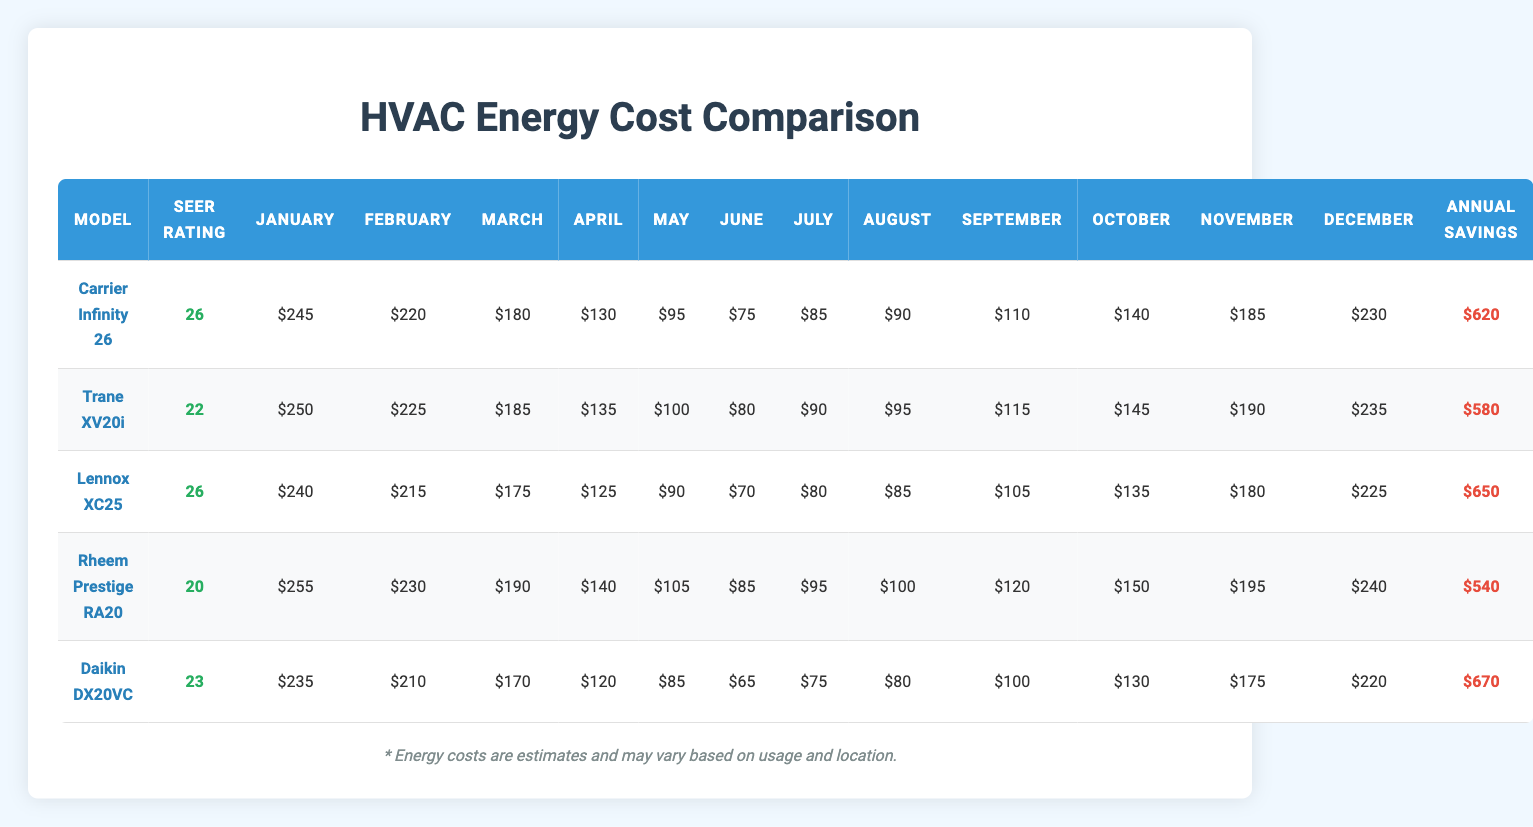What is the energy cost for the Carrier Infinity 26 in July? From the table, locate the row for the "Carrier Infinity 26" model. In the July column, the energy cost listed is $85.
Answer: $85 Which model has the highest SEER rating? By comparing the SEER ratings listed next to each model in the table, both the "Carrier Infinity 26" and "Lennox XC25" have the highest rating of 26.
Answer: Carrier Infinity 26 and Lennox XC25 What is the annual savings for the model with the lowest energy costs in July? First, check the July energy costs for all models. The lowest energy cost in July is $65 for the "Daikin DX20VC." The annual savings associated with this model, according to the table, is $670.
Answer: $670 What is the average monthly energy cost for all models in April? To find the average, sum the energy costs for April across all models: (130 + 135 + 125 + 140 + 120) = 650. There are 5 models, so the average is 650/5 = 130.
Answer: $130 Did the Rheem Prestige RA20 have lower energy costs than the Trane XV20i during the summer months (June, July, August)? Compare the energy costs for both models in the summer months. Rheem Prestige RA20 has costs of $85, $95, and $100 in June, July, and August respectively. Trane XV20i has costs of $80, $90, and $95. Since the costs for Trane XV20i are lower in June, July, and August, the statement is false.
Answer: No Which model had the most consistent monthly energy costs across the year? Assess the energy costs for each model month by month. The "Lennox XC25" has energy costs that vary minimally with the highest being $240 in December and the lowest being $175 in March which implies more consistency compared to others; thus it displays less fluctuation.
Answer: Lennox XC25 What is the total energy cost from January to March for the Daikin DX20VC model? Sum the energy costs for Daikin DX20VC in January, February, and March: $235 (January) + $210 (February) + $170 (March) = $615.
Answer: $615 Which model experiences the highest energy cost in December? Check the energy cost for December across all models. The "Rheem Prestige RA20" has the highest listed cost at $240 dollars.
Answer: Rheem Prestige RA20 Is it true that the Lennox XC25 has higher annual savings compared to the Carrier Infinity 26? The annual savings for Lennox XC25 is $650, and for Carrier Infinity 26, it is $620. Since $650 is greater than $620, the statement is true.
Answer: Yes What is the difference in annual savings between the model with the highest savings and the model with the lowest savings? Determine the highest annual savings ($670 for Daikin DX20VC) and the lowest annual savings ($540 for Rheem Prestige RA20). Calculate the difference: $670 - $540 = $130.
Answer: $130 